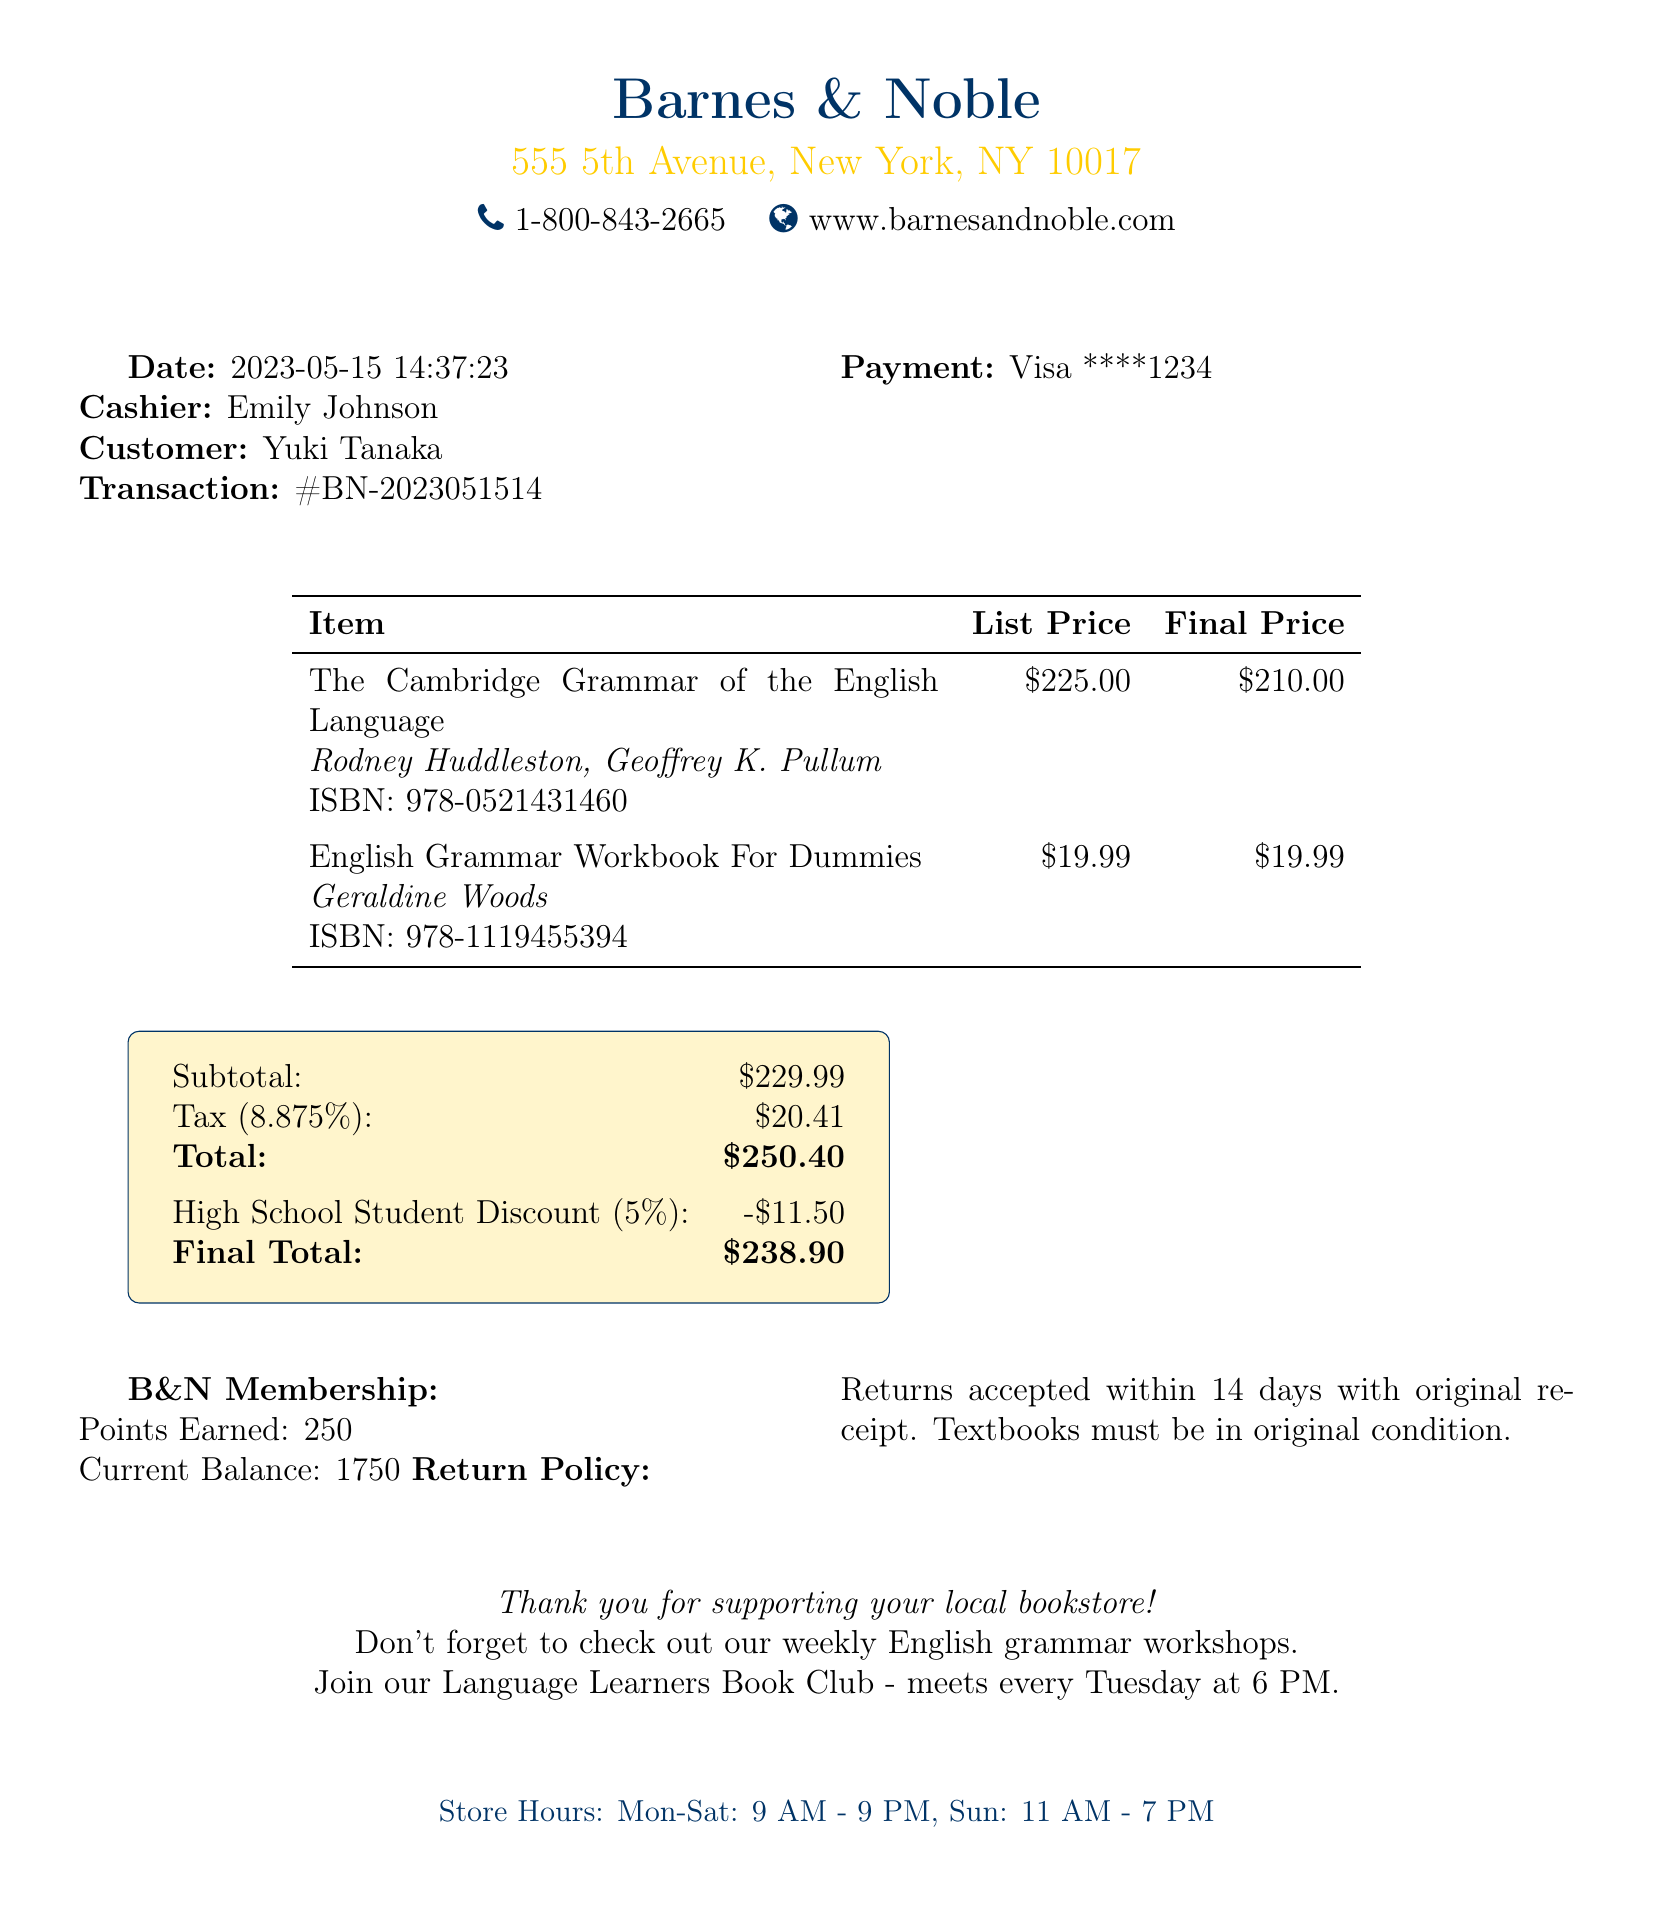What is the name of the bookstore? The name of the bookstore is listed at the top of the document.
Answer: Barnes & Noble Who was the cashier during this transaction? The cashier's name is mentioned near the transaction details.
Answer: Emily Johnson What was the date of the transaction? The transaction date is indicated just below the store information.
Answer: 2023-05-15 What is the total amount paid by the customer? The total amount is calculated at the end of the transaction details.
Answer: 250.40 How much was saved through the student discount? The amount saved by the student discount is displayed in the cost breakdown.
Answer: 11.50 What is the percentage of the student discount? The percentage for the student discount is specified in the discount information.
Answer: 5% What is the ISBN of the first textbook? The ISBN for the textbook is noted alongside the book title and author information.
Answer: 978-0521431460 How many loyalty points were earned from this transaction? The points earned from the B&N membership are indicated in the loyalty program section.
Answer: 250 What is the return policy period for textbooks? The return policy mentions the allowed time for returns clearly.
Answer: 14 days 